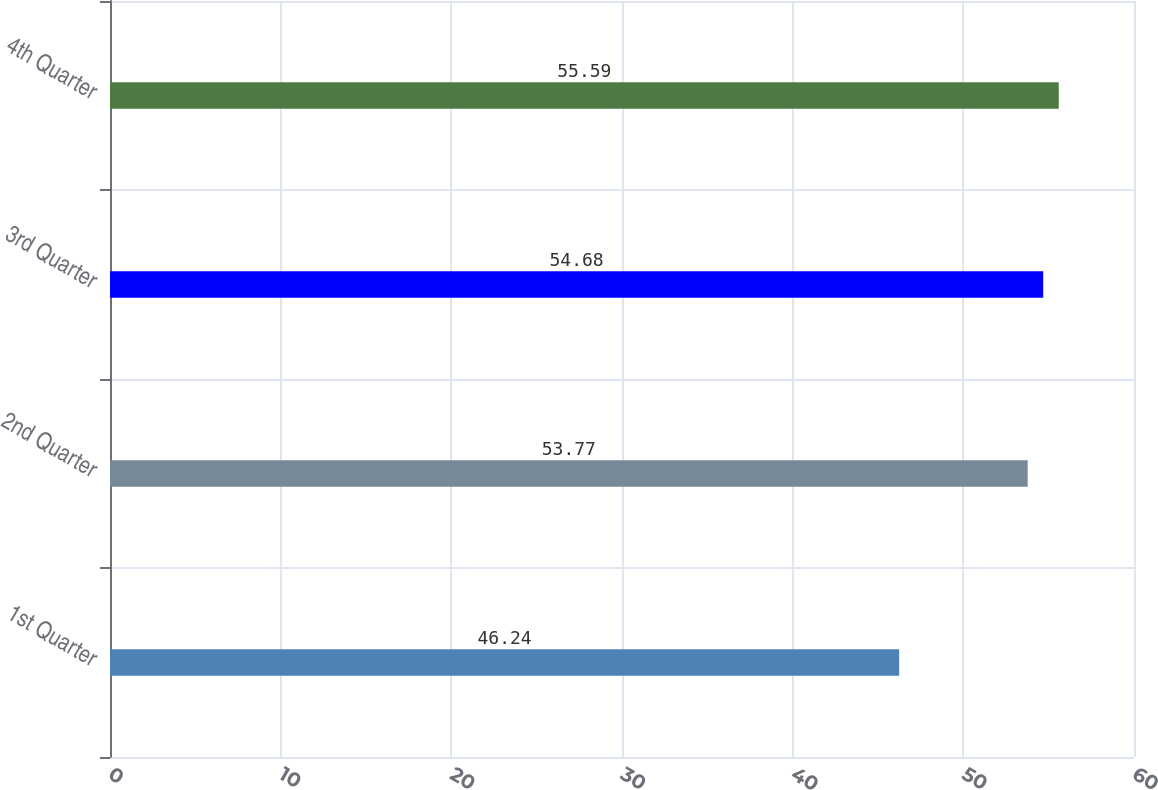Convert chart. <chart><loc_0><loc_0><loc_500><loc_500><bar_chart><fcel>1st Quarter<fcel>2nd Quarter<fcel>3rd Quarter<fcel>4th Quarter<nl><fcel>46.24<fcel>53.77<fcel>54.68<fcel>55.59<nl></chart> 